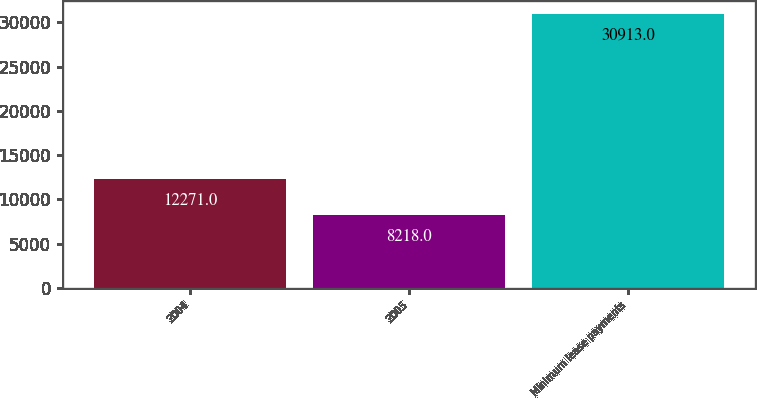Convert chart. <chart><loc_0><loc_0><loc_500><loc_500><bar_chart><fcel>2004<fcel>2005<fcel>Minimum lease payments<nl><fcel>12271<fcel>8218<fcel>30913<nl></chart> 